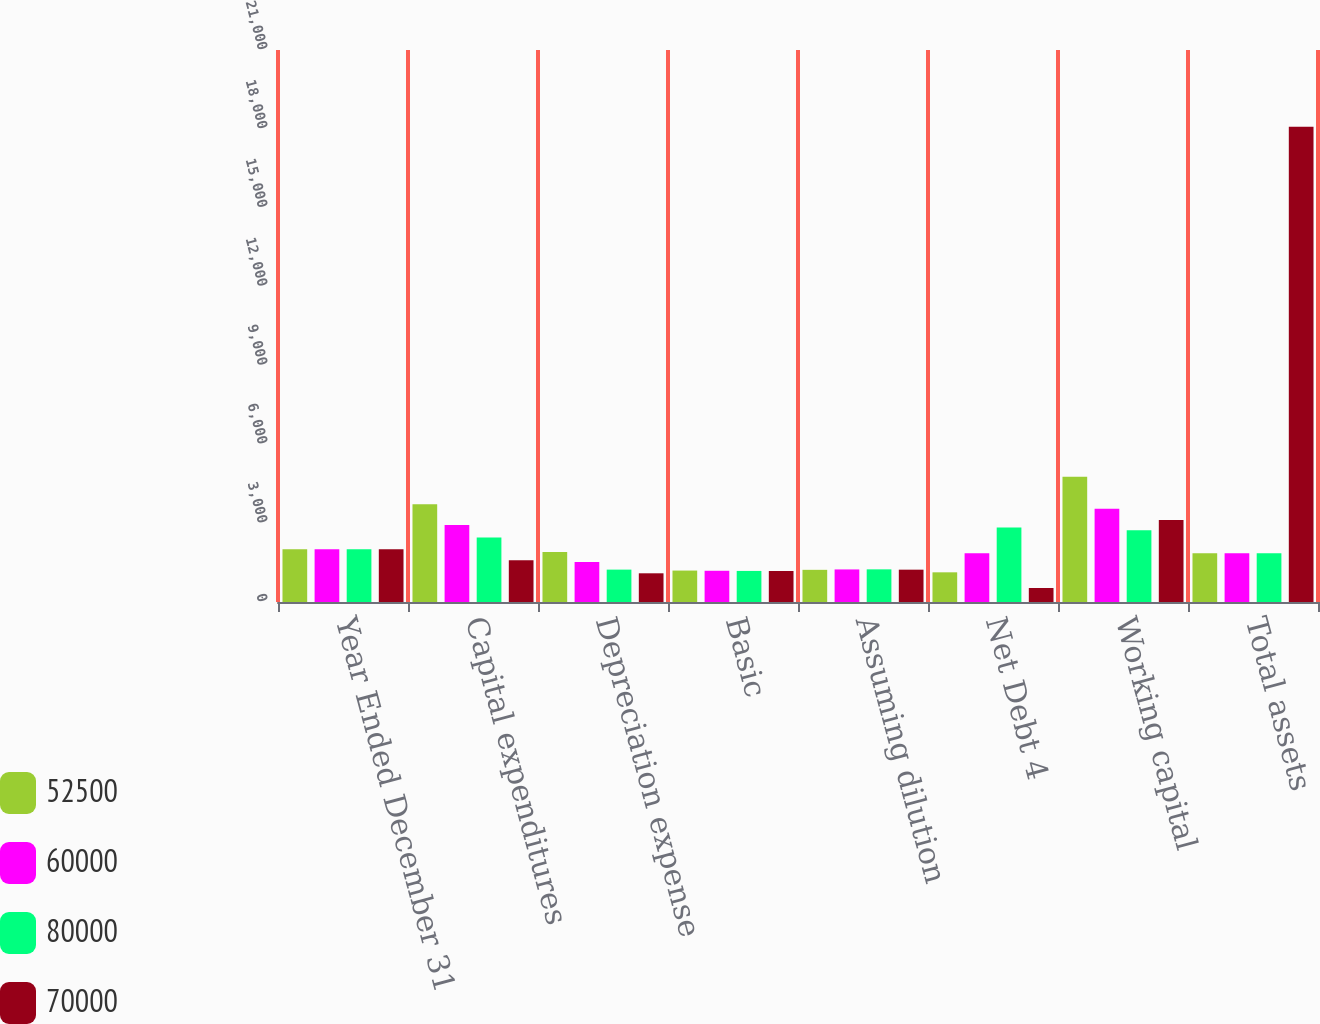Convert chart to OTSL. <chart><loc_0><loc_0><loc_500><loc_500><stacked_bar_chart><ecel><fcel>Year Ended December 31<fcel>Capital expenditures<fcel>Depreciation expense<fcel>Basic<fcel>Assuming dilution<fcel>Net Debt 4<fcel>Working capital<fcel>Total assets<nl><fcel>52500<fcel>2008<fcel>3723<fcel>1904<fcel>1196<fcel>1224<fcel>1129<fcel>4769<fcel>1857<nl><fcel>60000<fcel>2007<fcel>2931<fcel>1526<fcel>1188<fcel>1239<fcel>1857<fcel>3551<fcel>1857<nl><fcel>80000<fcel>2006<fcel>2457<fcel>1232<fcel>1182<fcel>1242<fcel>2834<fcel>2731<fcel>1857<nl><fcel>70000<fcel>2005<fcel>1593<fcel>1092<fcel>1179<fcel>1230<fcel>532<fcel>3121<fcel>18077<nl></chart> 